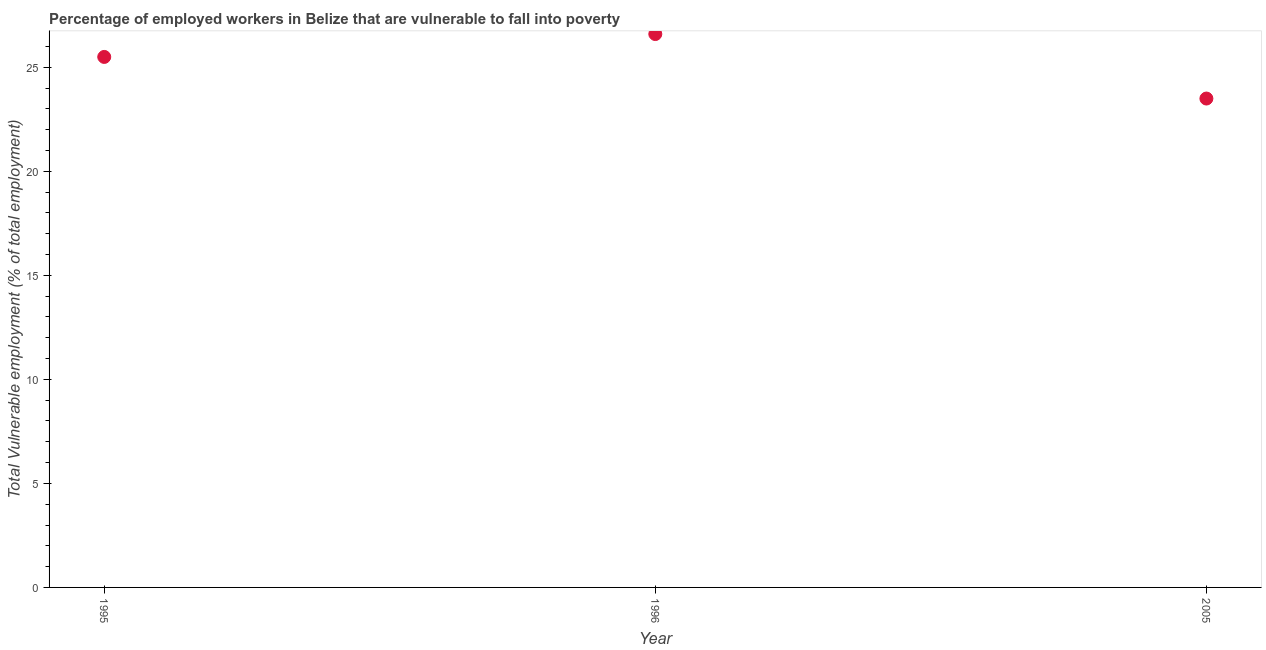What is the total vulnerable employment in 2005?
Provide a short and direct response. 23.5. Across all years, what is the maximum total vulnerable employment?
Offer a very short reply. 26.6. Across all years, what is the minimum total vulnerable employment?
Keep it short and to the point. 23.5. What is the sum of the total vulnerable employment?
Offer a terse response. 75.6. What is the difference between the total vulnerable employment in 1995 and 1996?
Provide a short and direct response. -1.1. What is the average total vulnerable employment per year?
Provide a succinct answer. 25.2. What is the median total vulnerable employment?
Your answer should be compact. 25.5. In how many years, is the total vulnerable employment greater than 7 %?
Provide a succinct answer. 3. Do a majority of the years between 2005 and 1996 (inclusive) have total vulnerable employment greater than 10 %?
Provide a succinct answer. No. What is the ratio of the total vulnerable employment in 1996 to that in 2005?
Your response must be concise. 1.13. Is the difference between the total vulnerable employment in 1995 and 1996 greater than the difference between any two years?
Provide a short and direct response. No. What is the difference between the highest and the second highest total vulnerable employment?
Your answer should be compact. 1.1. Is the sum of the total vulnerable employment in 1995 and 1996 greater than the maximum total vulnerable employment across all years?
Offer a very short reply. Yes. What is the difference between the highest and the lowest total vulnerable employment?
Give a very brief answer. 3.1. In how many years, is the total vulnerable employment greater than the average total vulnerable employment taken over all years?
Keep it short and to the point. 2. Does the total vulnerable employment monotonically increase over the years?
Give a very brief answer. No. How many dotlines are there?
Your answer should be compact. 1. What is the title of the graph?
Your answer should be compact. Percentage of employed workers in Belize that are vulnerable to fall into poverty. What is the label or title of the Y-axis?
Your answer should be very brief. Total Vulnerable employment (% of total employment). What is the Total Vulnerable employment (% of total employment) in 1996?
Offer a terse response. 26.6. What is the Total Vulnerable employment (% of total employment) in 2005?
Keep it short and to the point. 23.5. What is the difference between the Total Vulnerable employment (% of total employment) in 1995 and 2005?
Provide a succinct answer. 2. What is the ratio of the Total Vulnerable employment (% of total employment) in 1995 to that in 1996?
Your response must be concise. 0.96. What is the ratio of the Total Vulnerable employment (% of total employment) in 1995 to that in 2005?
Keep it short and to the point. 1.08. What is the ratio of the Total Vulnerable employment (% of total employment) in 1996 to that in 2005?
Offer a terse response. 1.13. 